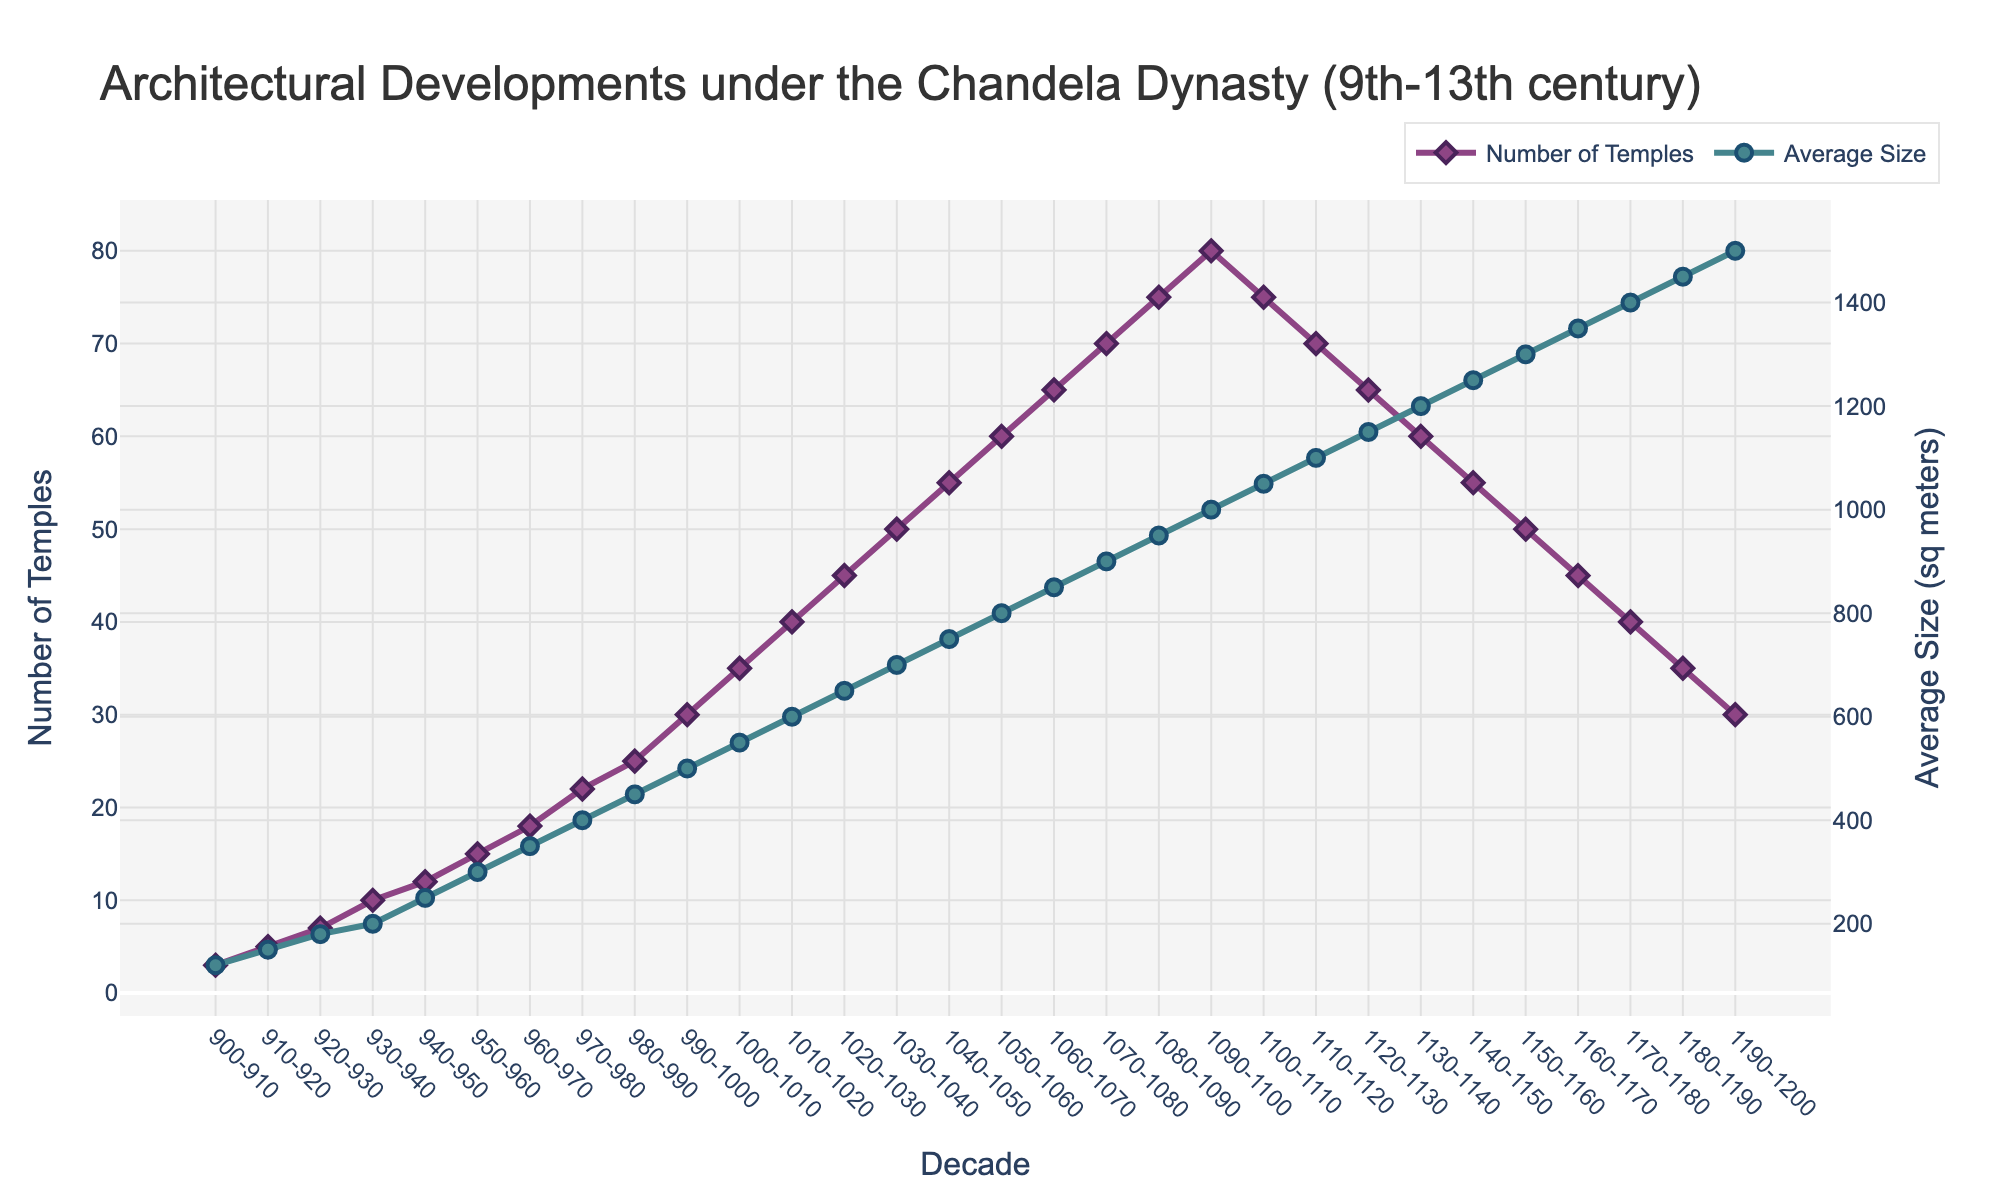What is the range of the number of temples built between 990-1000 and 1050-1060? The number of temples built in 990-1000 is 30, and in 1050-1060 is 60. The range is the difference between the two values. So, 60 - 30 = 30.
Answer: 30 Did the number of temples built increase or decrease from 1100-1110 to 1150-1160, and by how much? The number of temples built in 1100-1110 is 75, and in 1150-1160 is 50. The difference is 75 - 50 = 25, and since it's positive, there was a decrease by 25.
Answer: Decrease by 25 What was the average size of the temples built during the peak decade in terms of number of temples? The peak decade in terms of number of temples is 1090-1100 with 80 temples. The average size of the temples built in that period is 1000 square meters.
Answer: 1000 sq meters How many decades saw an increase in the average size of temples from the previous decade? From the data, each decade from 900-910 to 1190-1200 saw an increase in average size: 900-910 to 910-920, 910-920 to 920-930, and so on. The number of increases is each sequential step till this period: 29 increases.
Answer: 29 decades Which decade had the highest average size of temples and did it correspond to the highest number of temples built? The decade 1190-1200 had the highest average size of 1500 sq meters. However, it did not correspond to the highest number of temples, which was 80 in the decade 1090-1100.
Answer: 1190-1200; No What is the overall trend observed in the average size of temples from 900-910 to 1190-1200? The average size of temples increased steadily from 120 sq meters in 900-910 to 1500 sq meters in 1190-1200. This shows a consistent upward trend in temple size over the period.
Answer: Increasing trend Compare the number of temples built between the first and last decade provided. In the first decade (900-910), 3 temples were built. In the last decade (1190-1200), 30 temples were built. The increase is 30 - 3 = 27.
Answer: Increase by 27 What was the total number of temples built between 1000-1010 and 1060-1070? The number of temples built in 1000-1010 is 35, and in 1060-1070 is 65. The total is 35 + 65 = 100.
Answer: 100 Is there any decade where the average size of temples decreased compared to its preceding decade? From the data, no decade shows a decrease in the average size of temples compared to its preceding decade. The trend is always increasing.
Answer: No What can you infer about the relation between the number of temples built and the average size of temples over time? Initially, both the number of temples built and their average size grew. However, after reaching peak numbers around 1090-1100, the number of temples started to decline even though the average size continued to increase. This demonstrates an inverse relationship in later years.
Answer: Inverse relationship after peak 